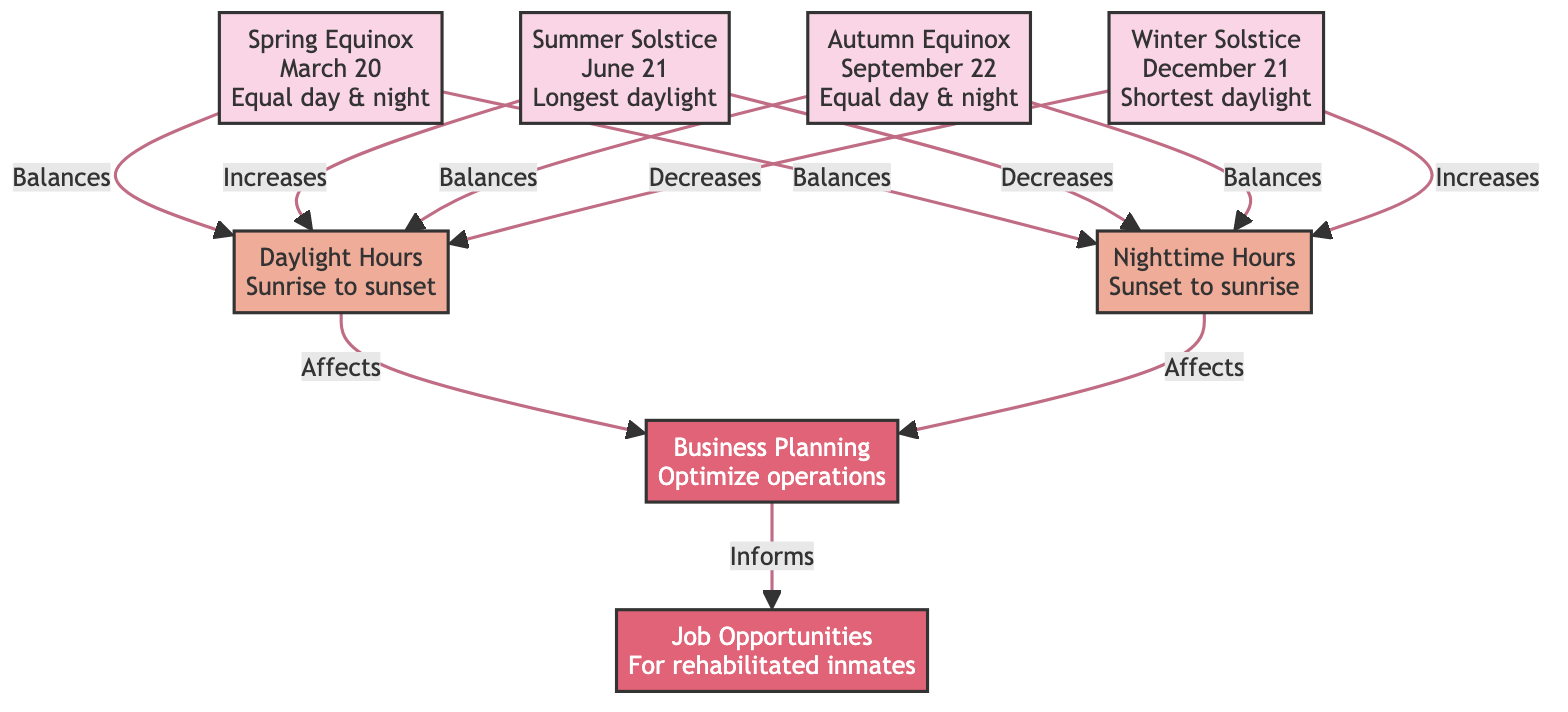What are the two equinoxes represented in the diagram? The diagram illustrates two equinoxes: the Spring Equinox and the Autumn Equinox. These are specifically noted in the season nodes as they both state "Equal day & night."
Answer: Spring Equinox, Autumn Equinox How many seasonal changes are depicted in the diagram? The diagram includes four seasonal changes, which are the Spring Equinox, Summer Solstice, Autumn Equinox, and Winter Solstice. Each is represented by a distinct node.
Answer: Four What effect does the summer solstice have on nighttime hours? The summer solstice indicates that nighttime hours decrease, as described in the relationship from the summer_solstice node to nighttime_hours in the diagram.
Answer: Decreases Which season is associated with the longest daylight hours? The summer solstice is specifically tied to the longest daylight hours, as indicated in its description within the diagram.
Answer: Summer Solstice What are the two factors that daylight hours affect for business planning? Daylight hours influence business planning and in turn inform job opportunities, according to the flow from daylight_hours to business_planning and then to job_opportunity.
Answer: Business Planning, Job Opportunities What is the relationship between the winter solstice and daytime hours? The winter solstice shows a direct relationship where it decreases daylight hours, indicating the decrease in available sunlight during this season.
Answer: Decreases How do seasonal changes relate to job opportunities? Seasonal changes affect daylight and nighttime hours, which in turn influence business planning; this planning informs the creation of job opportunities. Thus, there is a sequential relationship connecting these elements.
Answer: Informs During which season do day and night balance again? The day and night hours balance again during both the Spring Equinox and Autumn Equinox, as noted in their descriptions.
Answer: Spring Equinox, Autumn Equinox 